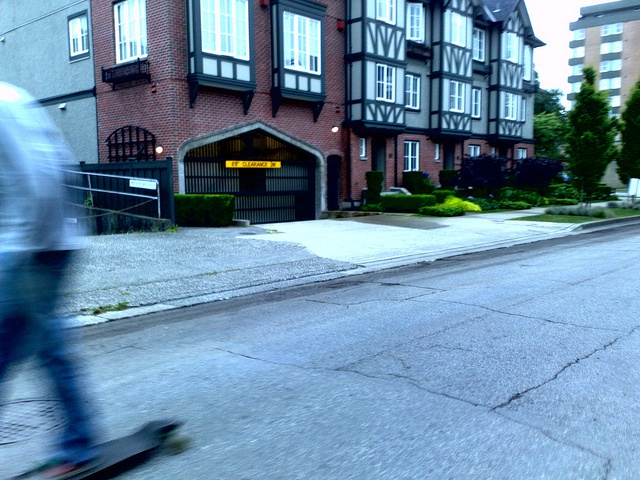Describe the objects in this image and their specific colors. I can see people in lightblue, navy, and blue tones and skateboard in lightblue, blue, navy, black, and gray tones in this image. 